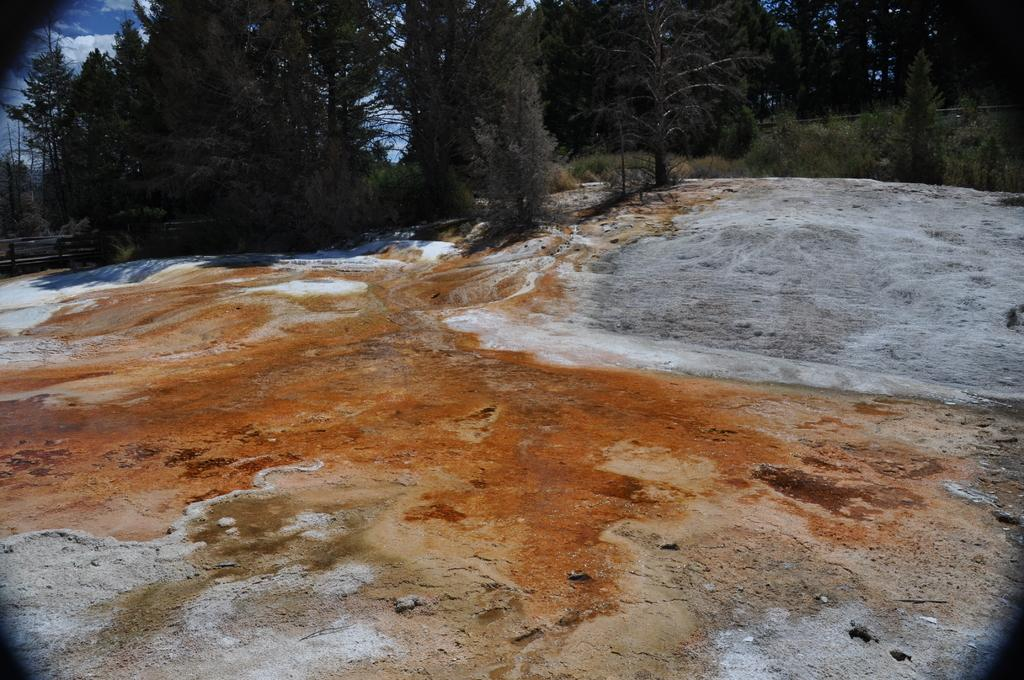What is the main subject in the center of the image? There is a rock in the center of the image. What can be seen in the background of the image? There are trees and the sky visible in the background of the image. What color of paint is used on the fan in the image? There is no fan present in the image, so it is not possible to determine the color of paint used on it. 